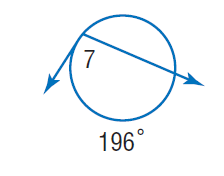Answer the mathemtical geometry problem and directly provide the correct option letter.
Question: Find \angle 7.
Choices: A: 41 B: 82 C: 98 D: 186 C 